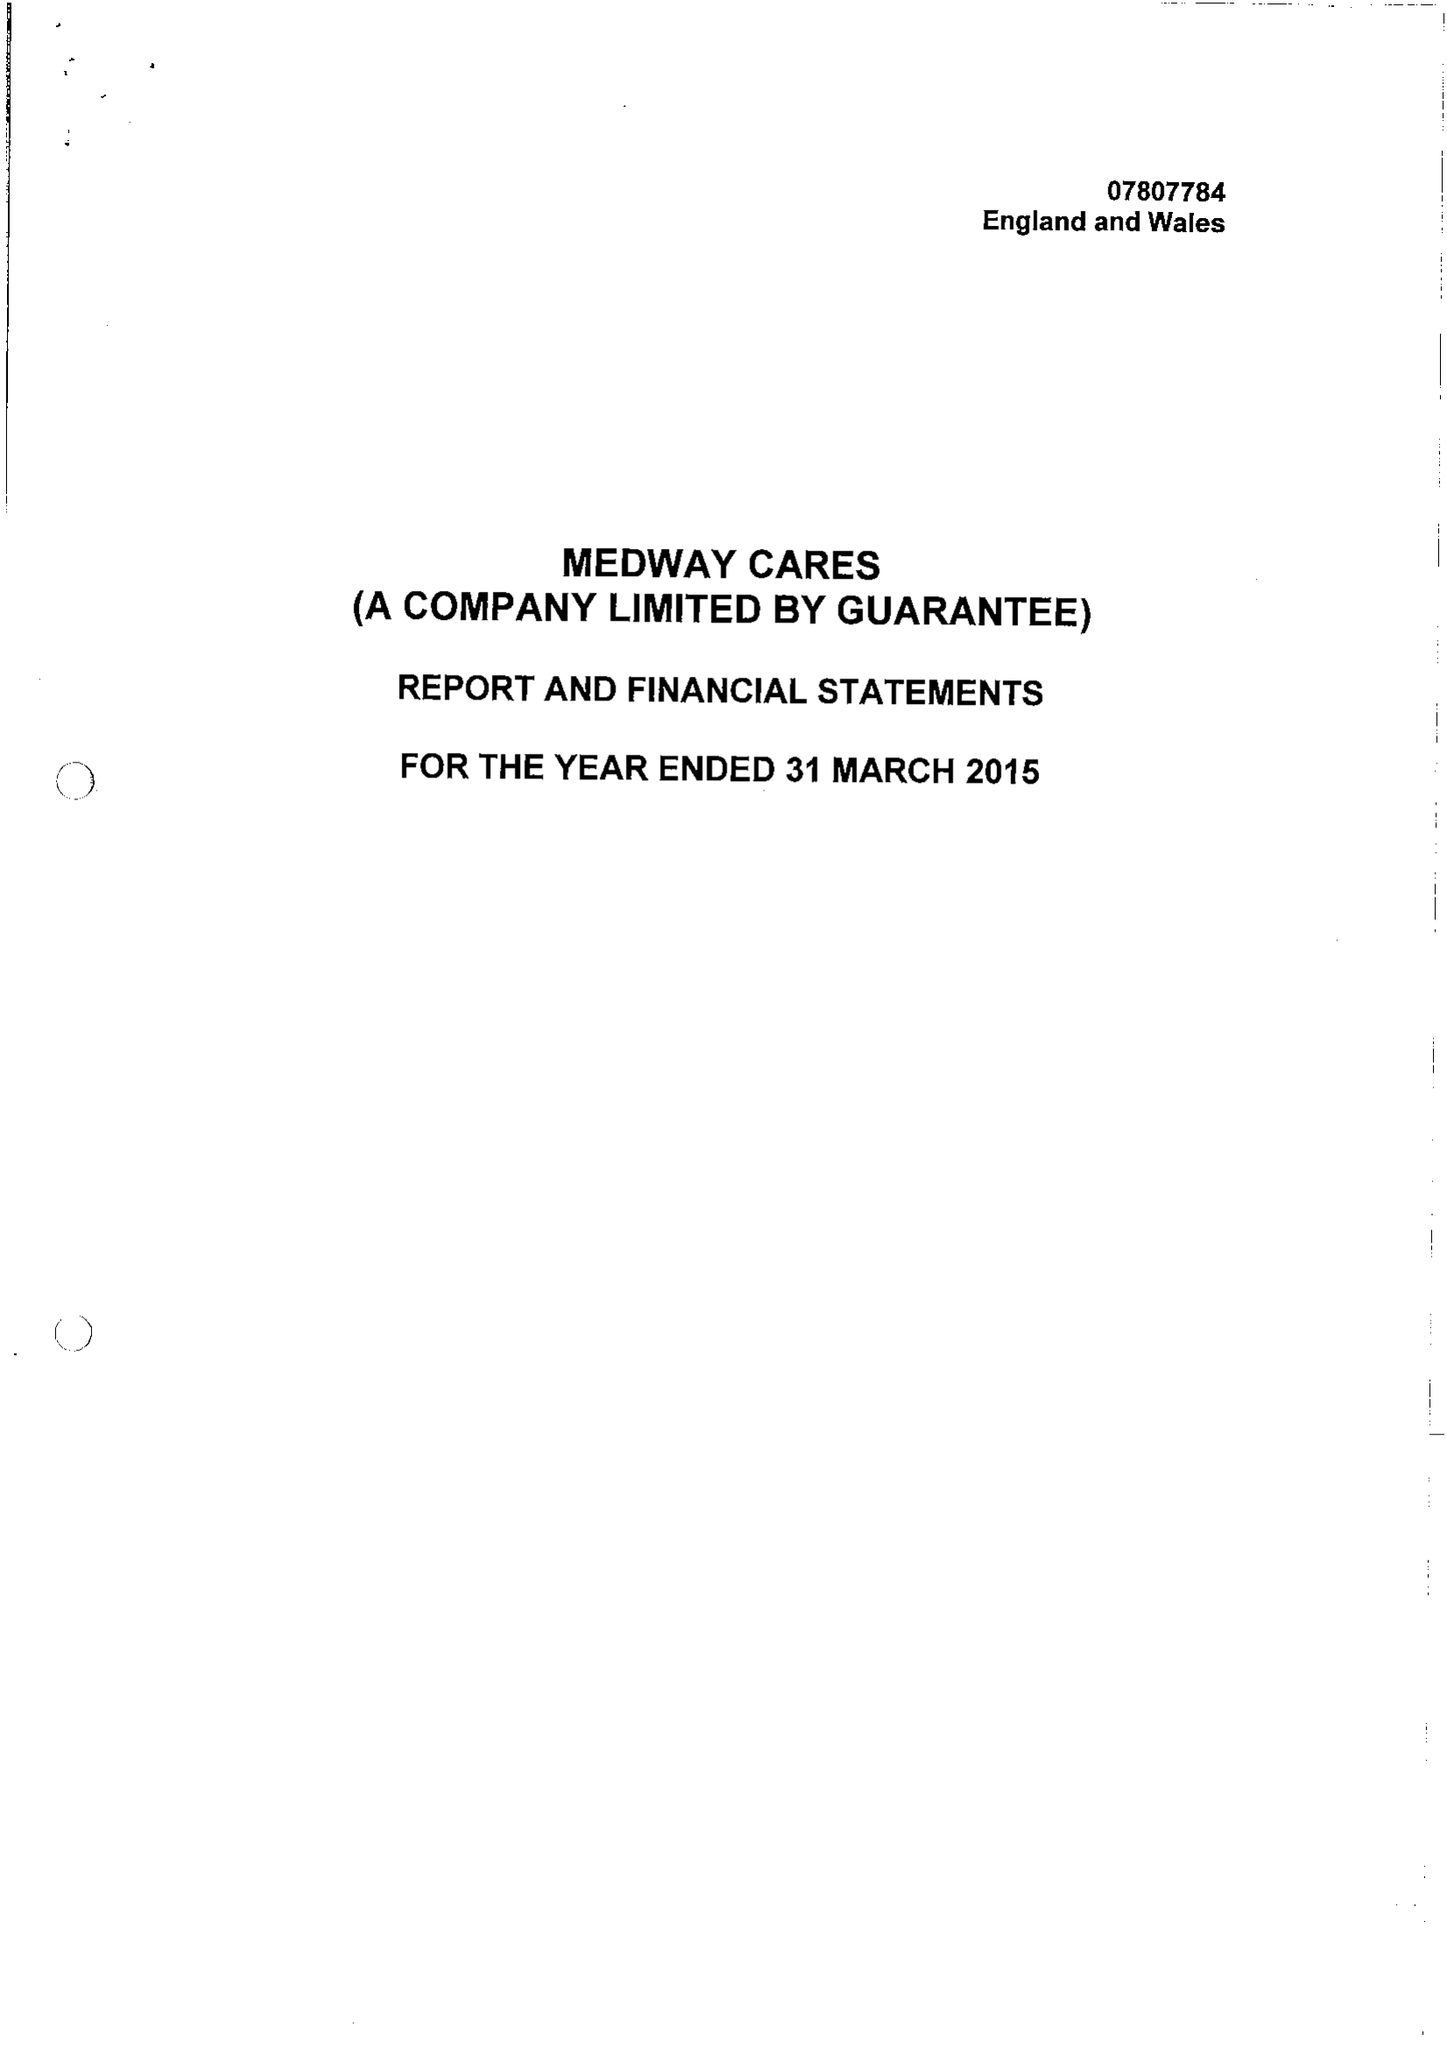What is the value for the charity_name?
Answer the question using a single word or phrase. Medway Cares Ltd. 